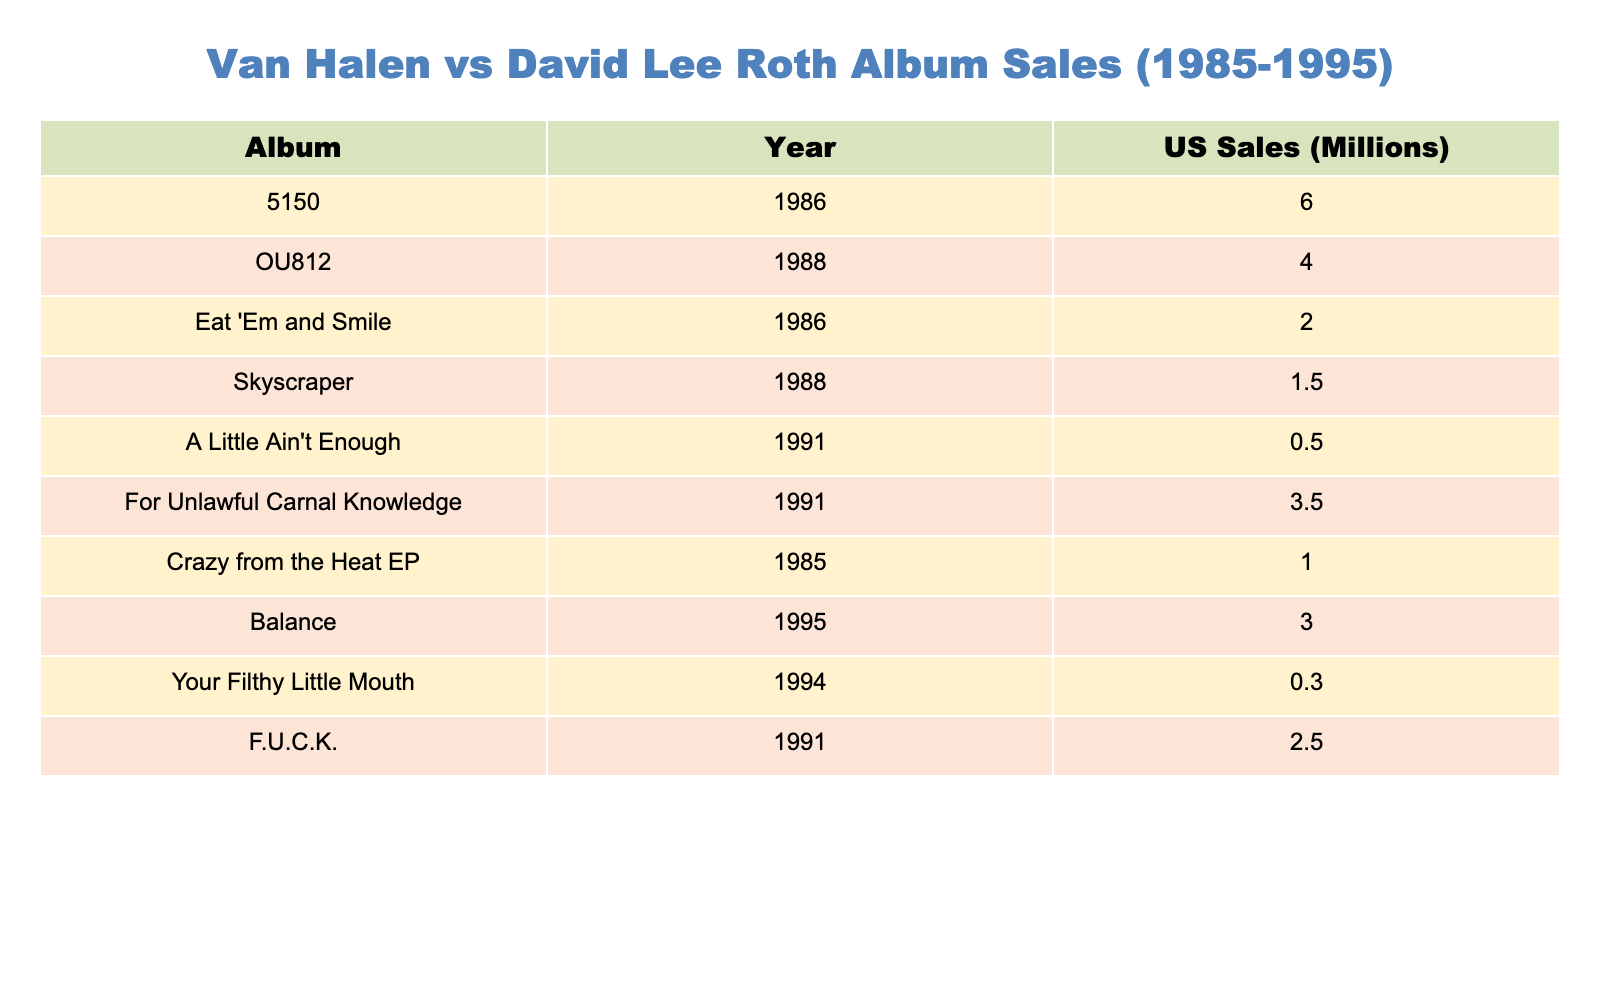What is the total US sales for Van Halen albums from 1985 to 1990? The Van Halen albums from 1985 to 1990 are 5150 (6 million), OU812 (4 million), and For Unlawful Carnal Knowledge (3.5 million). Adding these sales together: 6 + 4 + 3.5 = 13.5 million.
Answer: 13.5 million Which David Lee Roth album has the highest sales? Among David Lee Roth's albums listed, Eat 'Em and Smile has the highest sales at 2 million.
Answer: 2 million Did any David Lee Roth album outsell the Van Halen album OU812? OU812 had sales of 4 million. The highest selling Roth album, Eat 'Em and Smile, only sold 2 million, meaning no Roth album outsold OU812.
Answer: No What is the average sales of David Lee Roth's albums during this period? The sales for David Lee Roth's albums are 2 million for Eat 'Em and Smile, 1.5 million for Skyscraper, and 0.5 million for A Little Ain't Enough. Therefore, the average is (2 + 1.5 + 0.5) / 3 = 1 million.
Answer: 1 million Which Van Halen album has the lowest sales? The albums listed are 5150 (6 million), OU812 (4 million), and For Unlawful Carnal Knowledge (3.5 million). The lowest of these is For Unlawful Carnal Knowledge with 3.5 million.
Answer: 3.5 million If we sum all the US sales of both David Lee Roth and Van Halen albums from 1985 to 1990, what do we get? The total sales for Van Halen is 13.5 million, and for David Lee Roth, it is 4 million (2 + 1.5 + 0.5). Thus, the total combined sales is 13.5 + 4 = 17.5 million.
Answer: 17.5 million Is the sales of Crazy from the Heat EP greater than the combined sales of Skyscraper and A Little Ain't Enough? Crazy from the Heat EP has sales of 1 million. Skyscraper has 1.5 million and A Little Ain't Enough has 0.5 million, combining for 1.5 + 0.5 = 2 million. Since 1 million is less than 2 million, the statement is false.
Answer: No What proportion of sales do Van Halen albums represent compared to all albums listed (both Van Halen and David Lee Roth)? The total sales for all albums is 13.5 million (Van Halen) + 4 million (David Lee Roth) = 17.5 million. The proportion for Van Halen is then 13.5 / 17.5, which is approximately 0.77 or 77%.
Answer: 77% 